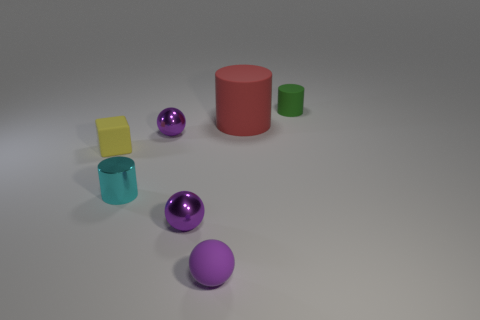How many matte spheres are in front of the small metal thing that is on the left side of the ball that is behind the cyan metallic thing?
Ensure brevity in your answer.  1. What color is the large rubber thing that is the same shape as the cyan shiny thing?
Your answer should be very brief. Red. There is a tiny purple shiny object in front of the tiny object that is to the left of the tiny cylinder to the left of the small rubber sphere; what is its shape?
Offer a very short reply. Sphere. There is a object that is in front of the metal cylinder and behind the small purple matte ball; what size is it?
Make the answer very short. Small. Are there fewer red objects than tiny metal spheres?
Your answer should be compact. Yes. What is the size of the cylinder that is right of the large matte cylinder?
Your answer should be very brief. Small. The object that is both on the right side of the tiny rubber ball and in front of the tiny rubber cylinder has what shape?
Your response must be concise. Cylinder. There is a green matte object that is the same shape as the tiny cyan object; what size is it?
Your answer should be compact. Small. How many other small yellow blocks have the same material as the small cube?
Your response must be concise. 0. There is a tiny matte cube; is it the same color as the tiny cylinder in front of the small green thing?
Provide a succinct answer. No. 